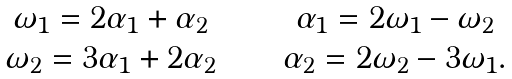<formula> <loc_0><loc_0><loc_500><loc_500>\begin{matrix} \omega _ { 1 } = 2 \alpha _ { 1 } + \alpha _ { 2 } & \quad & \alpha _ { 1 } = 2 \omega _ { 1 } - \omega _ { 2 } \\ \omega _ { 2 } = 3 \alpha _ { 1 } + 2 \alpha _ { 2 } & \quad & \alpha _ { 2 } = 2 \omega _ { 2 } - 3 \omega _ { 1 } . \end{matrix}</formula> 